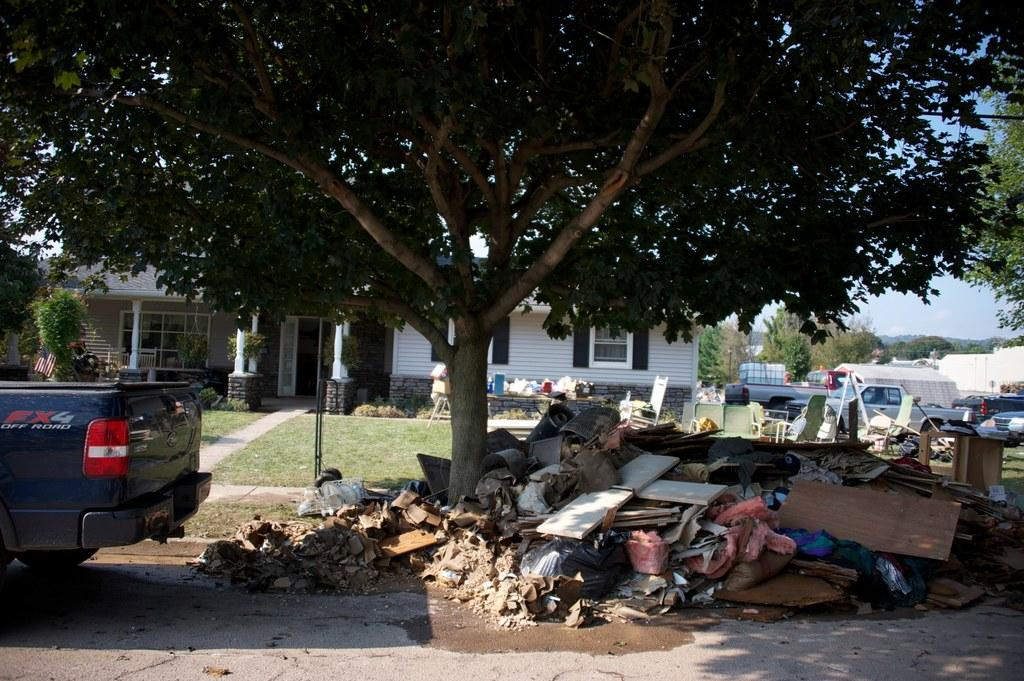What type of material is used for the planks in the image? The wooden planks in the image are made of wood. What can be seen hanging or placed on the planks? Clothes are visible in the image. What type of vehicles are present in the image? There are vehicles in the image, but the specific type is not mentioned. What type of vegetation is present in the image? Grass and trees are present in the image. What type of furniture is in the image? There is a chair in the image. What type of structure is visible in the image? There is a building with windows in the image. What else can be seen in the image? There are some objects in the image, but their specific nature is not mentioned. What is visible in the background of the image? The sky is visible in the background of the image. Is there a rainstorm happening in the image? No, there is no indication of a rainstorm in the image. What type of fiction is being read by the trees in the image? There are no trees reading fiction in the image, as trees do not have the ability to read. 